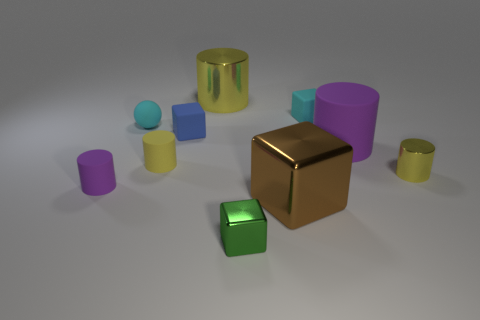What is the material of the small cyan ball right of the small purple rubber thing?
Make the answer very short. Rubber. What is the material of the green object that is the same shape as the small blue object?
Give a very brief answer. Metal. There is a cyan matte object left of the large metal cube; is there a yellow metallic thing that is behind it?
Provide a succinct answer. Yes. Does the small purple thing have the same shape as the blue thing?
Offer a terse response. No. What is the shape of the large brown object that is the same material as the tiny green thing?
Make the answer very short. Cube. There is a purple rubber thing that is on the left side of the large rubber cylinder; is its size the same as the yellow shiny cylinder that is left of the large brown object?
Ensure brevity in your answer.  No. Are there more large shiny cylinders in front of the cyan cube than tiny cyan blocks to the left of the small purple matte object?
Ensure brevity in your answer.  No. What number of other objects are the same color as the big matte object?
Give a very brief answer. 1. Is the color of the large block the same as the block behind the tiny blue cube?
Offer a very short reply. No. What number of big brown shiny things are behind the tiny shiny object that is in front of the tiny purple object?
Offer a very short reply. 1. 